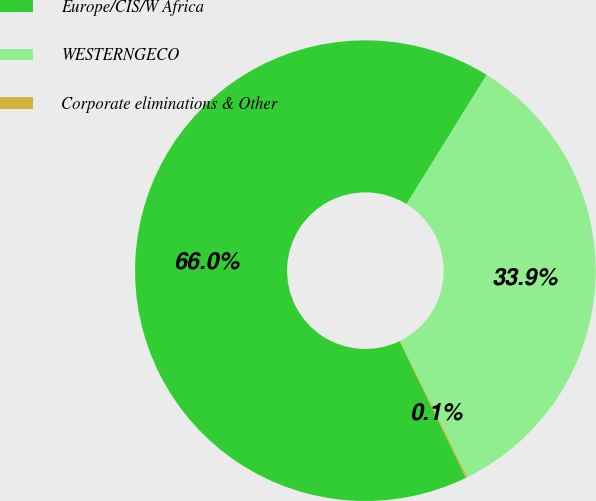<chart> <loc_0><loc_0><loc_500><loc_500><pie_chart><fcel>Europe/CIS/W Africa<fcel>WESTERNGECO<fcel>Corporate eliminations & Other<nl><fcel>66.03%<fcel>33.86%<fcel>0.11%<nl></chart> 